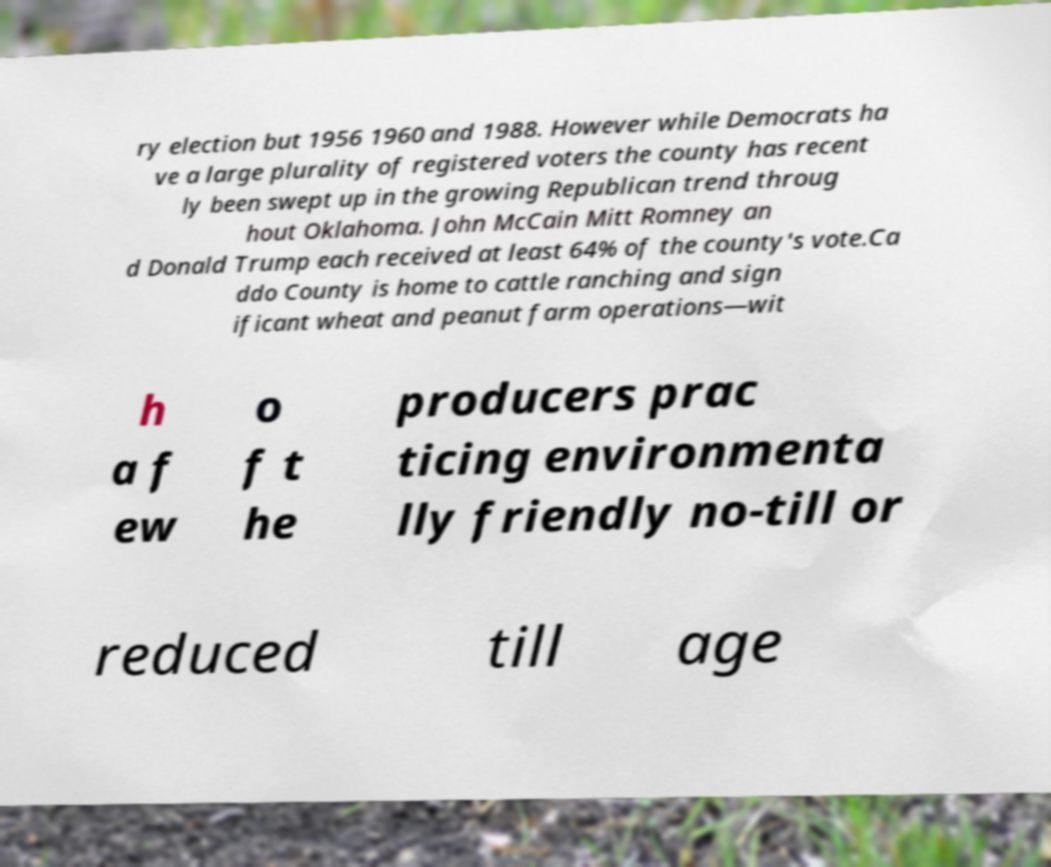Can you accurately transcribe the text from the provided image for me? ry election but 1956 1960 and 1988. However while Democrats ha ve a large plurality of registered voters the county has recent ly been swept up in the growing Republican trend throug hout Oklahoma. John McCain Mitt Romney an d Donald Trump each received at least 64% of the county's vote.Ca ddo County is home to cattle ranching and sign ificant wheat and peanut farm operations—wit h a f ew o f t he producers prac ticing environmenta lly friendly no-till or reduced till age 